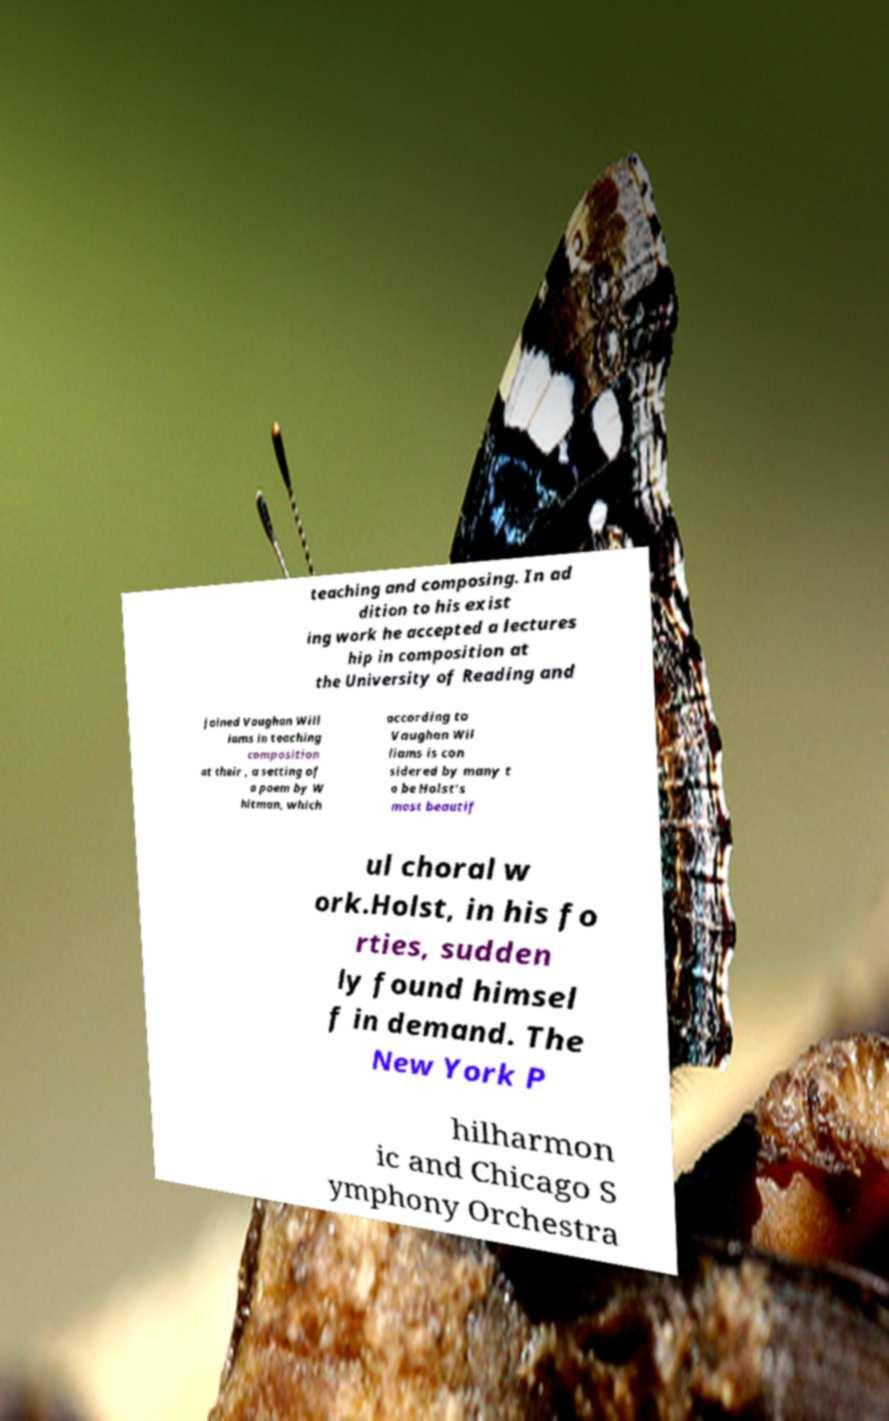For documentation purposes, I need the text within this image transcribed. Could you provide that? teaching and composing. In ad dition to his exist ing work he accepted a lectures hip in composition at the University of Reading and joined Vaughan Will iams in teaching composition at their , a setting of a poem by W hitman, which according to Vaughan Wil liams is con sidered by many t o be Holst's most beautif ul choral w ork.Holst, in his fo rties, sudden ly found himsel f in demand. The New York P hilharmon ic and Chicago S ymphony Orchestra 